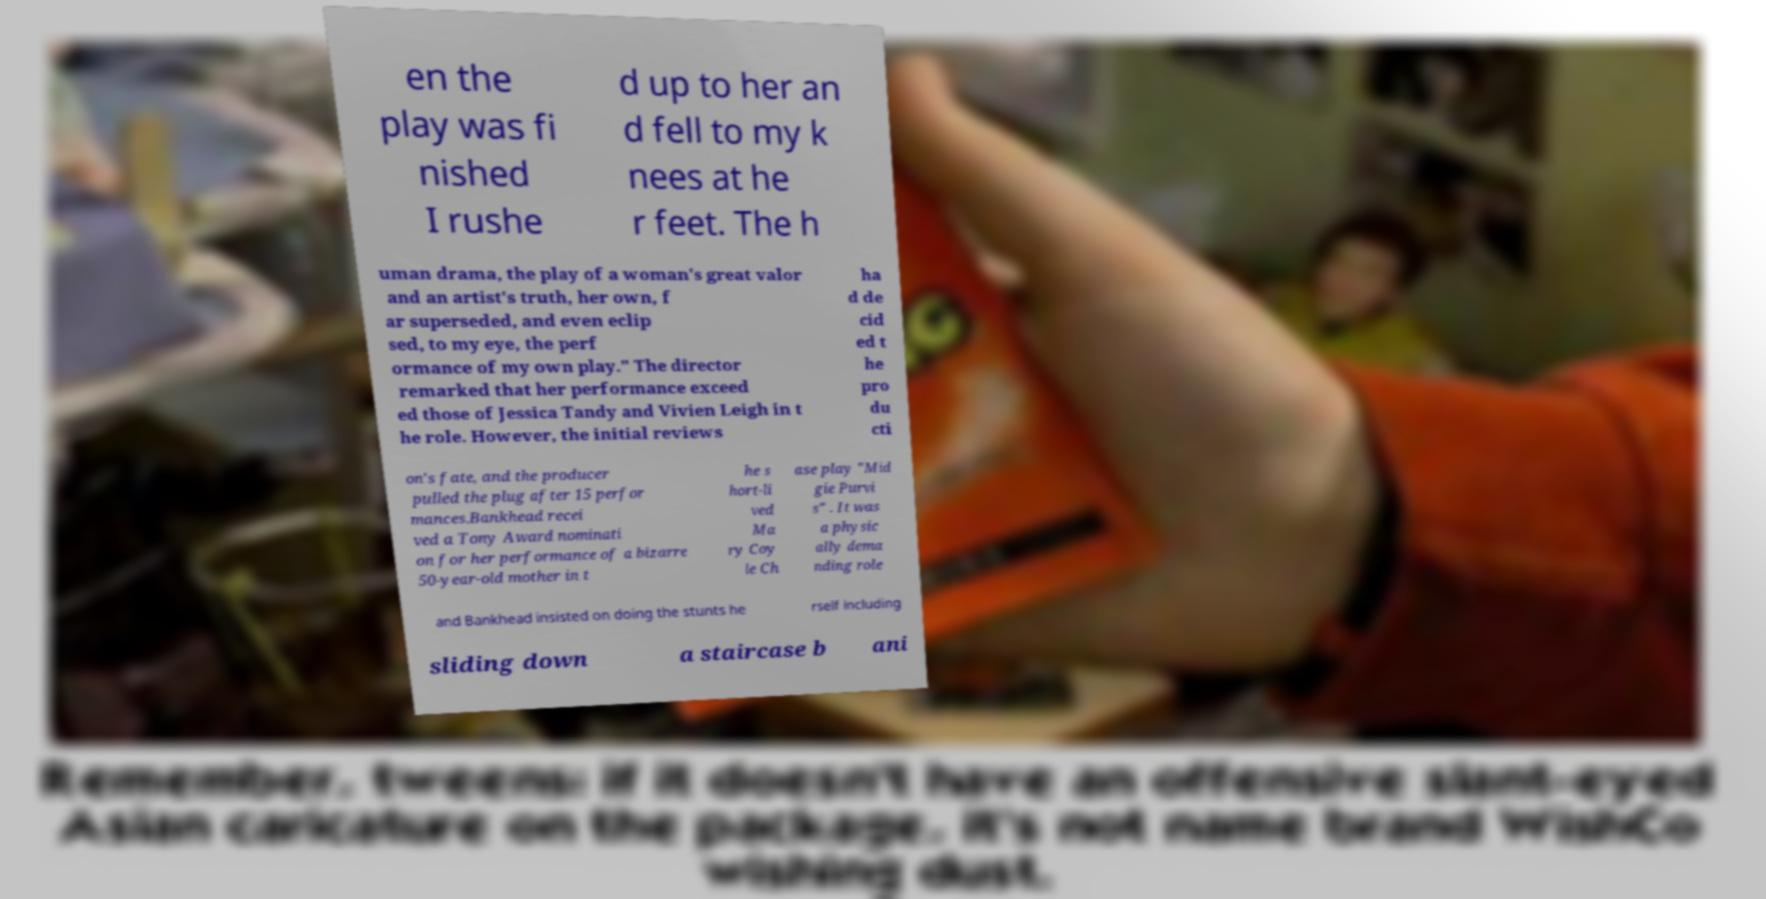For documentation purposes, I need the text within this image transcribed. Could you provide that? en the play was fi nished I rushe d up to her an d fell to my k nees at he r feet. The h uman drama, the play of a woman's great valor and an artist's truth, her own, f ar superseded, and even eclip sed, to my eye, the perf ormance of my own play." The director remarked that her performance exceed ed those of Jessica Tandy and Vivien Leigh in t he role. However, the initial reviews ha d de cid ed t he pro du cti on's fate, and the producer pulled the plug after 15 perfor mances.Bankhead recei ved a Tony Award nominati on for her performance of a bizarre 50-year-old mother in t he s hort-li ved Ma ry Coy le Ch ase play "Mid gie Purvi s" . It was a physic ally dema nding role and Bankhead insisted on doing the stunts he rself including sliding down a staircase b ani 